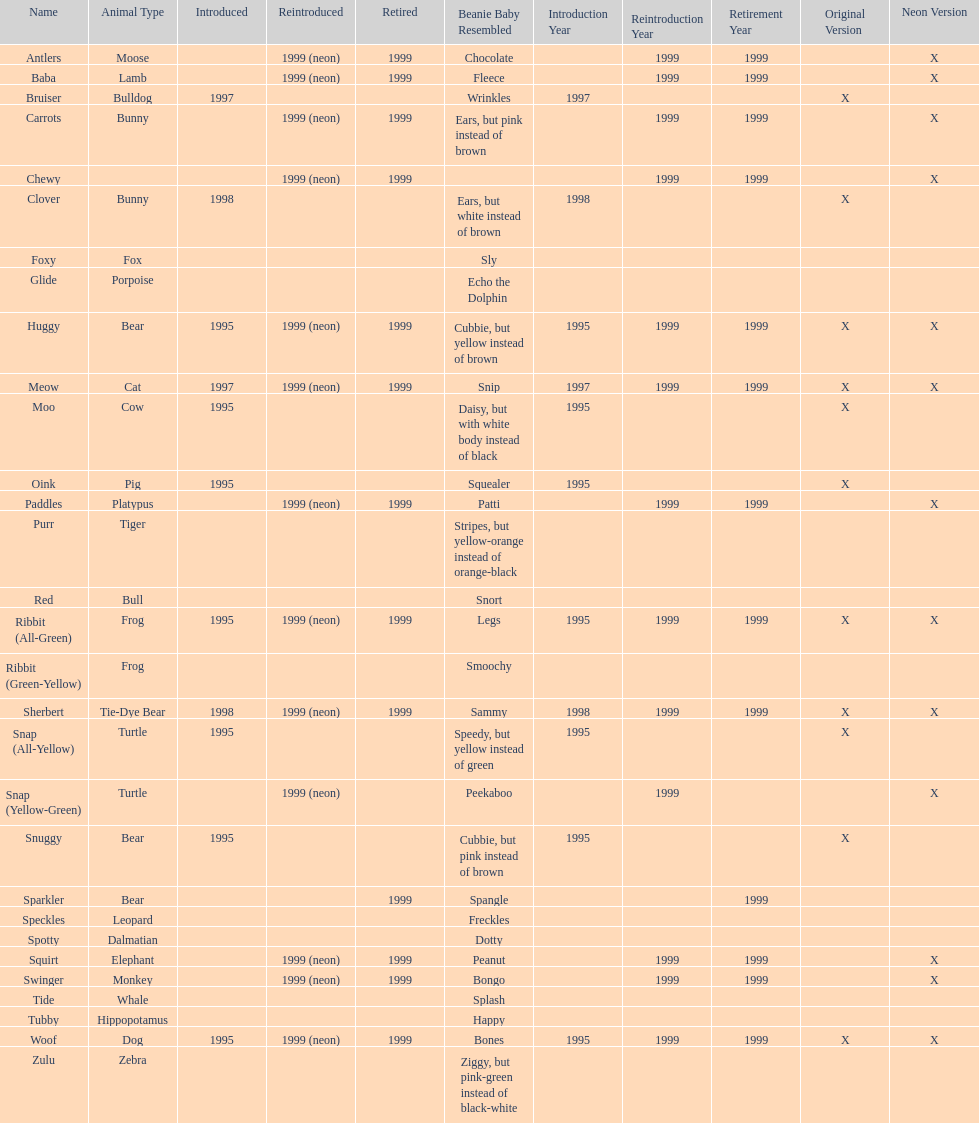Help me parse the entirety of this table. {'header': ['Name', 'Animal Type', 'Introduced', 'Reintroduced', 'Retired', 'Beanie Baby Resembled', 'Introduction Year', 'Reintroduction Year', 'Retirement Year', 'Original Version', 'Neon Version'], 'rows': [['Antlers', 'Moose', '', '1999 (neon)', '1999', 'Chocolate', '', '1999', '1999', '', 'X'], ['Baba', 'Lamb', '', '1999 (neon)', '1999', 'Fleece', '', '1999', '1999', '', 'X'], ['Bruiser', 'Bulldog', '1997', '', '', 'Wrinkles', '1997', '', '', 'X', ''], ['Carrots', 'Bunny', '', '1999 (neon)', '1999', 'Ears, but pink instead of brown', '', '1999', '1999', '', 'X'], ['Chewy', '', '', '1999 (neon)', '1999', '', '', '1999', '1999', '', 'X'], ['Clover', 'Bunny', '1998', '', '', 'Ears, but white instead of brown', '1998', '', '', 'X', ''], ['Foxy', 'Fox', '', '', '', 'Sly', '', '', '', '', ''], ['Glide', 'Porpoise', '', '', '', 'Echo the Dolphin', '', '', '', '', ''], ['Huggy', 'Bear', '1995', '1999 (neon)', '1999', 'Cubbie, but yellow instead of brown', '1995', '1999', '1999', 'X', 'X'], ['Meow', 'Cat', '1997', '1999 (neon)', '1999', 'Snip', '1997', '1999', '1999', 'X', 'X'], ['Moo', 'Cow', '1995', '', '', 'Daisy, but with white body instead of black', '1995', '', '', 'X', ''], ['Oink', 'Pig', '1995', '', '', 'Squealer', '1995', '', '', 'X', ''], ['Paddles', 'Platypus', '', '1999 (neon)', '1999', 'Patti', '', '1999', '1999', '', 'X'], ['Purr', 'Tiger', '', '', '', 'Stripes, but yellow-orange instead of orange-black', '', '', '', '', ''], ['Red', 'Bull', '', '', '', 'Snort', '', '', '', '', ''], ['Ribbit (All-Green)', 'Frog', '1995', '1999 (neon)', '1999', 'Legs', '1995', '1999', '1999', 'X', 'X'], ['Ribbit (Green-Yellow)', 'Frog', '', '', '', 'Smoochy', '', '', '', '', ''], ['Sherbert', 'Tie-Dye Bear', '1998', '1999 (neon)', '1999', 'Sammy', '1998', '1999', '1999', 'X', 'X'], ['Snap (All-Yellow)', 'Turtle', '1995', '', '', 'Speedy, but yellow instead of green', '1995', '', '', 'X', ''], ['Snap (Yellow-Green)', 'Turtle', '', '1999 (neon)', '', 'Peekaboo', '', '1999', '', '', 'X'], ['Snuggy', 'Bear', '1995', '', '', 'Cubbie, but pink instead of brown', '1995', '', '', 'X', ''], ['Sparkler', 'Bear', '', '', '1999', 'Spangle', '', '', '1999', '', ''], ['Speckles', 'Leopard', '', '', '', 'Freckles', '', '', '', '', ''], ['Spotty', 'Dalmatian', '', '', '', 'Dotty', '', '', '', '', ''], ['Squirt', 'Elephant', '', '1999 (neon)', '1999', 'Peanut', '', '1999', '1999', '', 'X'], ['Swinger', 'Monkey', '', '1999 (neon)', '1999', 'Bongo', '', '1999', '1999', '', 'X'], ['Tide', 'Whale', '', '', '', 'Splash', '', '', '', '', ''], ['Tubby', 'Hippopotamus', '', '', '', 'Happy', '', '', '', '', ''], ['Woof', 'Dog', '1995', '1999 (neon)', '1999', 'Bones', '1995', '1999', '1999', 'X', 'X'], ['Zulu', 'Zebra', '', '', '', 'Ziggy, but pink-green instead of black-white', '', '', '', '', '']]} Name the only pillow pal that is a dalmatian. Spotty. 